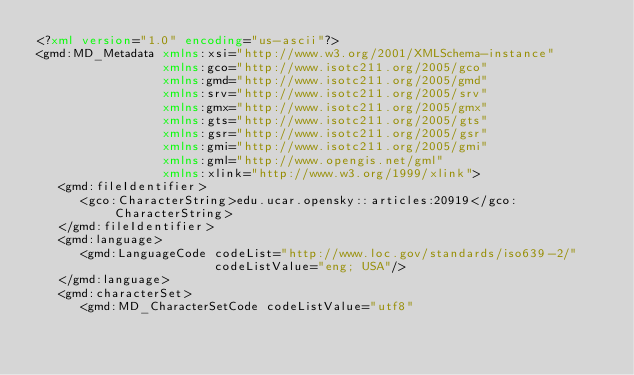Convert code to text. <code><loc_0><loc_0><loc_500><loc_500><_XML_><?xml version="1.0" encoding="us-ascii"?>
<gmd:MD_Metadata xmlns:xsi="http://www.w3.org/2001/XMLSchema-instance"
                 xmlns:gco="http://www.isotc211.org/2005/gco"
                 xmlns:gmd="http://www.isotc211.org/2005/gmd"
                 xmlns:srv="http://www.isotc211.org/2005/srv"
                 xmlns:gmx="http://www.isotc211.org/2005/gmx"
                 xmlns:gts="http://www.isotc211.org/2005/gts"
                 xmlns:gsr="http://www.isotc211.org/2005/gsr"
                 xmlns:gmi="http://www.isotc211.org/2005/gmi"
                 xmlns:gml="http://www.opengis.net/gml"
                 xmlns:xlink="http://www.w3.org/1999/xlink">
   <gmd:fileIdentifier>
      <gco:CharacterString>edu.ucar.opensky::articles:20919</gco:CharacterString>
   </gmd:fileIdentifier>
   <gmd:language>
      <gmd:LanguageCode codeList="http://www.loc.gov/standards/iso639-2/"
                        codeListValue="eng; USA"/>
   </gmd:language>
   <gmd:characterSet>
      <gmd:MD_CharacterSetCode codeListValue="utf8"</code> 